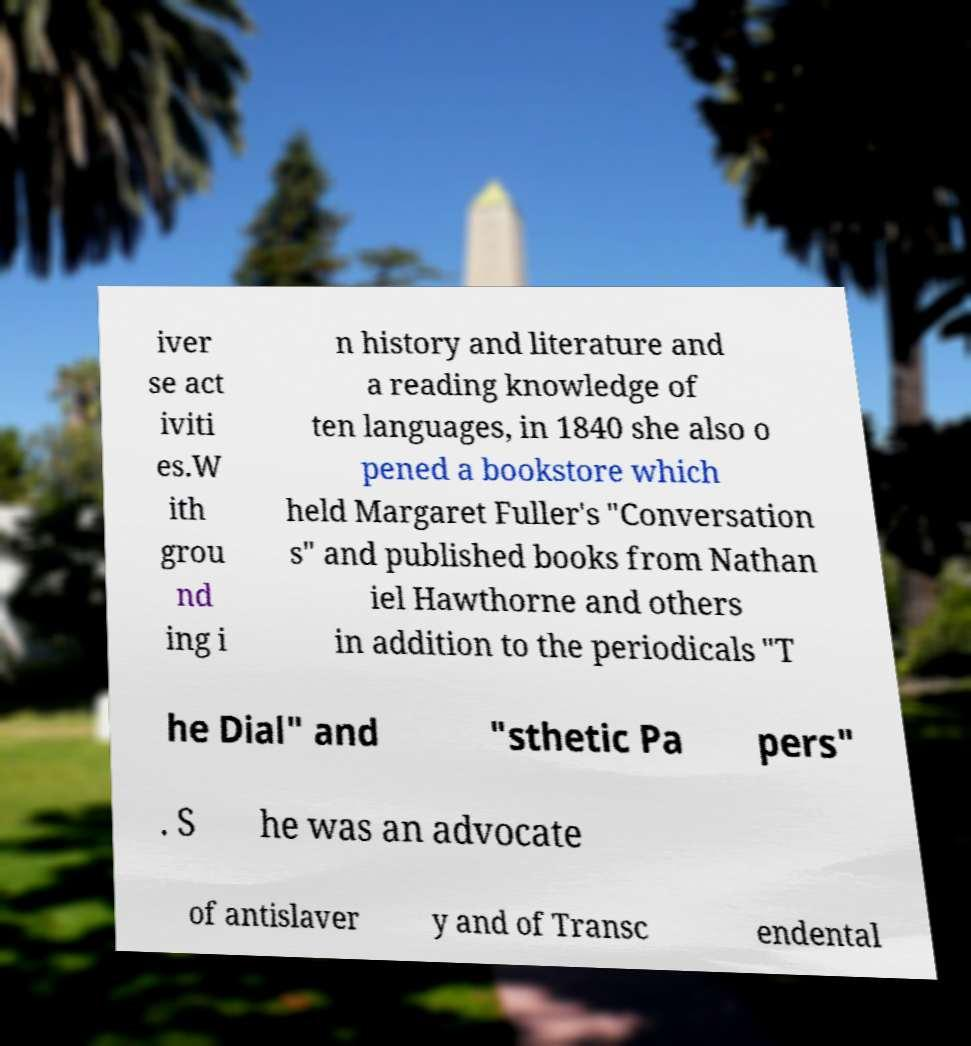There's text embedded in this image that I need extracted. Can you transcribe it verbatim? iver se act iviti es.W ith grou nd ing i n history and literature and a reading knowledge of ten languages, in 1840 she also o pened a bookstore which held Margaret Fuller's "Conversation s" and published books from Nathan iel Hawthorne and others in addition to the periodicals "T he Dial" and "sthetic Pa pers" . S he was an advocate of antislaver y and of Transc endental 